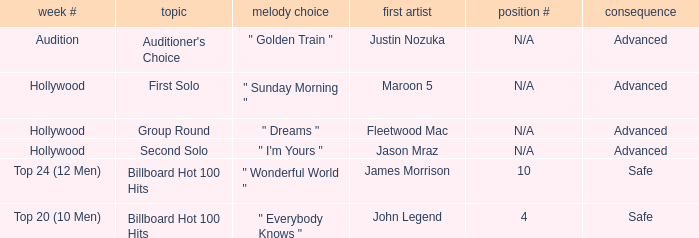What are all the week # where subject matter is auditioner's choice Audition. 